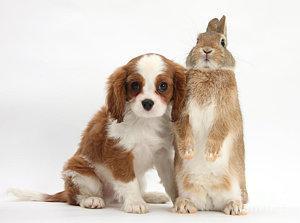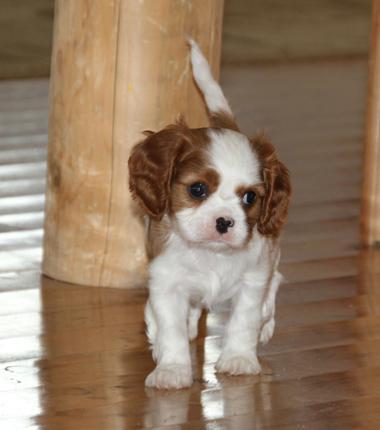The first image is the image on the left, the second image is the image on the right. Analyze the images presented: Is the assertion "An image shows two furry animals side-by-side." valid? Answer yes or no. Yes. The first image is the image on the left, the second image is the image on the right. Assess this claim about the two images: "There are exactly two animals in the image on the left.". Correct or not? Answer yes or no. Yes. The first image is the image on the left, the second image is the image on the right. Assess this claim about the two images: "There is exactly one animal sitting in the image on the left.". Correct or not? Answer yes or no. No. 